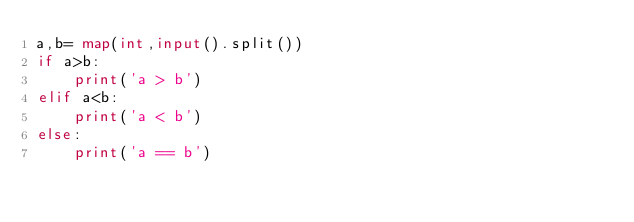<code> <loc_0><loc_0><loc_500><loc_500><_Python_>a,b= map(int,input().split())
if a>b:
    print('a > b')
elif a<b:
    print('a < b')
else:
    print('a == b')
</code> 